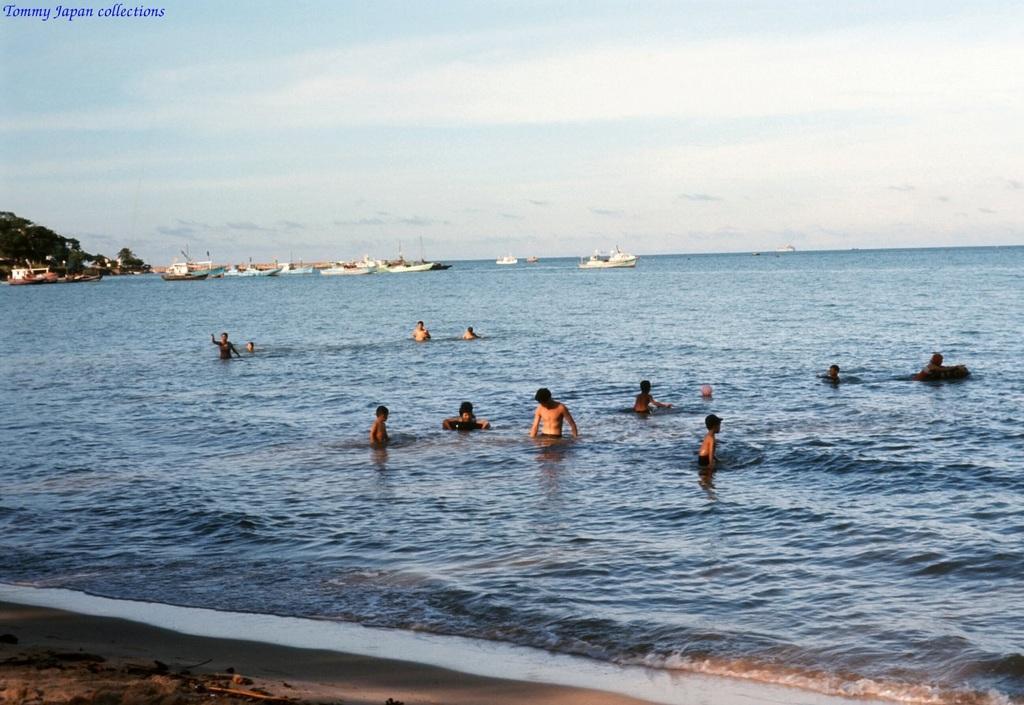Please provide a concise description of this image. In this image I can see water and in it I can see few people and number of boats. In the background I can see sky and here I can see watermark. 